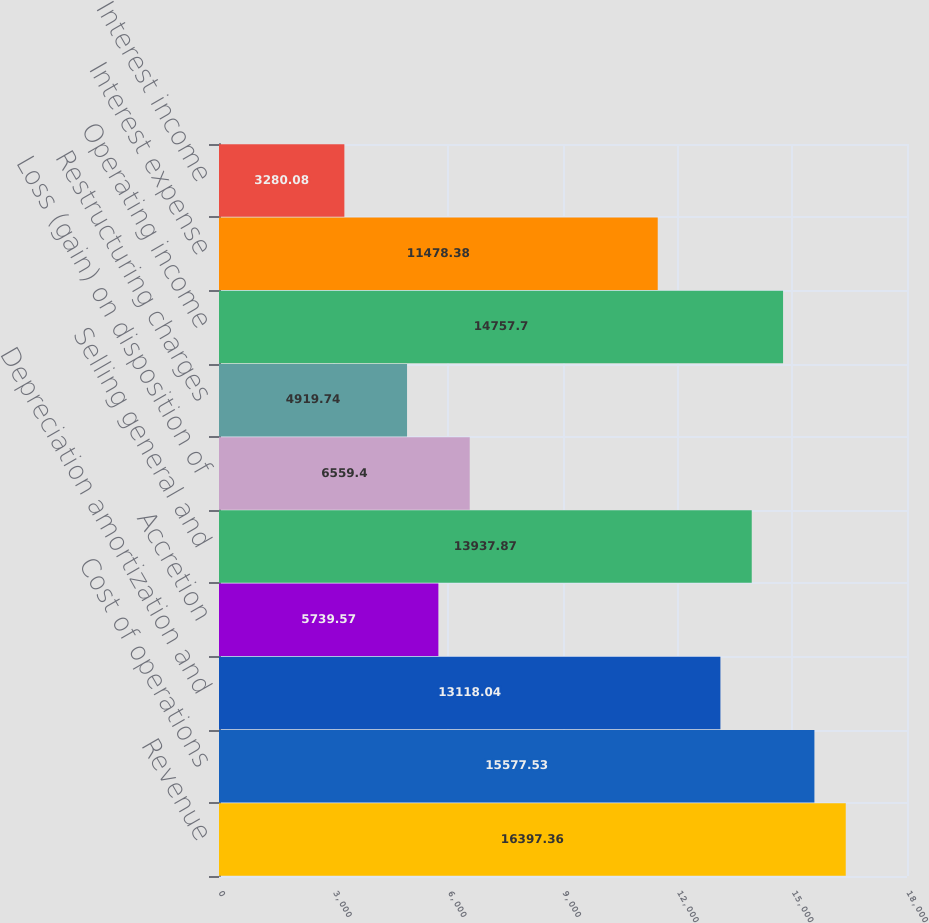Convert chart to OTSL. <chart><loc_0><loc_0><loc_500><loc_500><bar_chart><fcel>Revenue<fcel>Cost of operations<fcel>Depreciation amortization and<fcel>Accretion<fcel>Selling general and<fcel>Loss (gain) on disposition of<fcel>Restructuring charges<fcel>Operating income<fcel>Interest expense<fcel>Interest income<nl><fcel>16397.4<fcel>15577.5<fcel>13118<fcel>5739.57<fcel>13937.9<fcel>6559.4<fcel>4919.74<fcel>14757.7<fcel>11478.4<fcel>3280.08<nl></chart> 